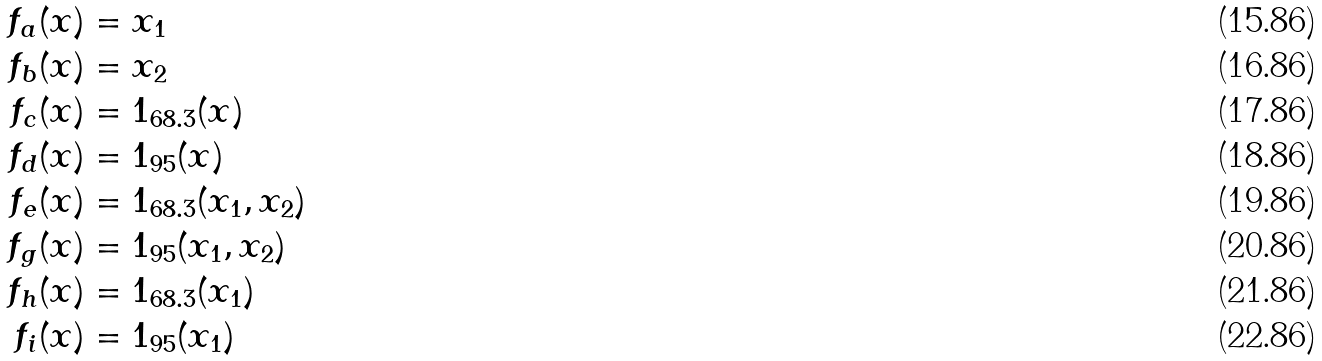Convert formula to latex. <formula><loc_0><loc_0><loc_500><loc_500>f _ { a } ( x ) & = x _ { 1 } \\ f _ { b } ( x ) & = x _ { 2 } \\ f _ { c } ( x ) & = 1 _ { 6 8 . 3 } ( x ) \\ f _ { d } ( x ) & = 1 _ { 9 5 } ( x ) \\ f _ { e } ( x ) & = 1 _ { 6 8 . 3 } ( x _ { 1 } , x _ { 2 } ) \\ f _ { g } ( x ) & = 1 _ { 9 5 } ( x _ { 1 } , x _ { 2 } ) \\ f _ { h } ( x ) & = 1 _ { 6 8 . 3 } ( x _ { 1 } ) \\ f _ { i } ( x ) & = 1 _ { 9 5 } ( x _ { 1 } )</formula> 